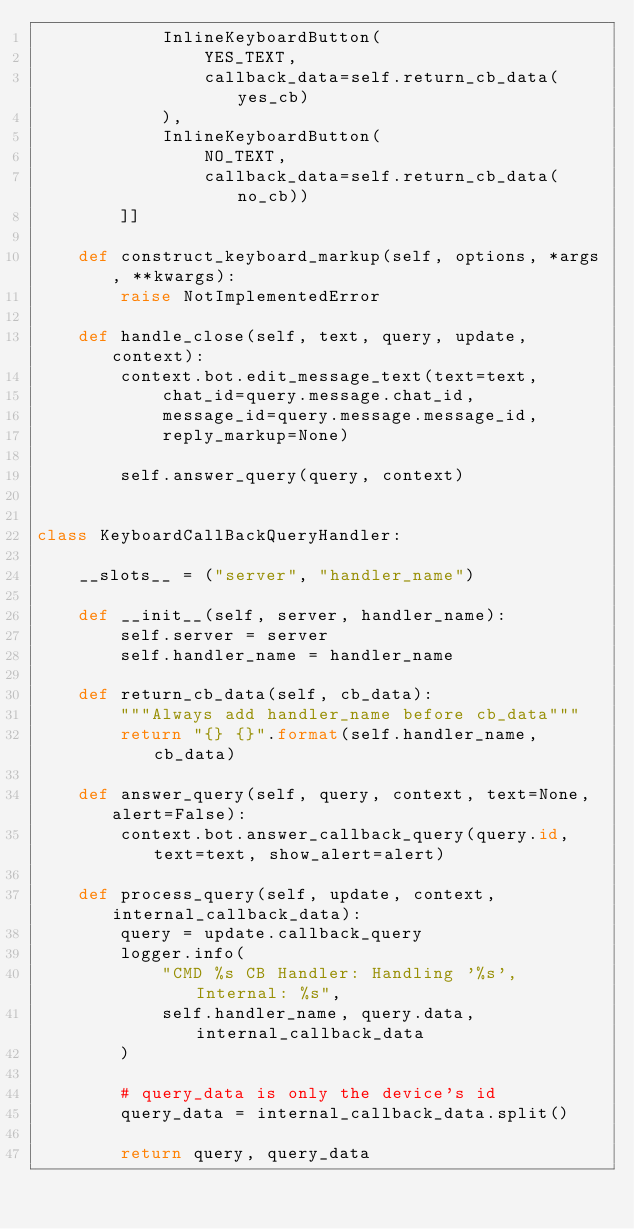Convert code to text. <code><loc_0><loc_0><loc_500><loc_500><_Python_>            InlineKeyboardButton(
                YES_TEXT,
                callback_data=self.return_cb_data(yes_cb)
            ),
            InlineKeyboardButton(
                NO_TEXT,
                callback_data=self.return_cb_data(no_cb))
        ]]

    def construct_keyboard_markup(self, options, *args, **kwargs):
        raise NotImplementedError

    def handle_close(self, text, query, update, context):
        context.bot.edit_message_text(text=text,
            chat_id=query.message.chat_id,
            message_id=query.message.message_id,
            reply_markup=None)

        self.answer_query(query, context)


class KeyboardCallBackQueryHandler:

    __slots__ = ("server", "handler_name")

    def __init__(self, server, handler_name):
        self.server = server
        self.handler_name = handler_name

    def return_cb_data(self, cb_data):
        """Always add handler_name before cb_data"""
        return "{} {}".format(self.handler_name, cb_data)

    def answer_query(self, query, context, text=None, alert=False):
        context.bot.answer_callback_query(query.id, text=text, show_alert=alert)

    def process_query(self, update, context, internal_callback_data):
        query = update.callback_query
        logger.info(
            "CMD %s CB Handler: Handling '%s', Internal: %s",
            self.handler_name, query.data, internal_callback_data
        )

        # query_data is only the device's id
        query_data = internal_callback_data.split()

        return query, query_data
</code> 